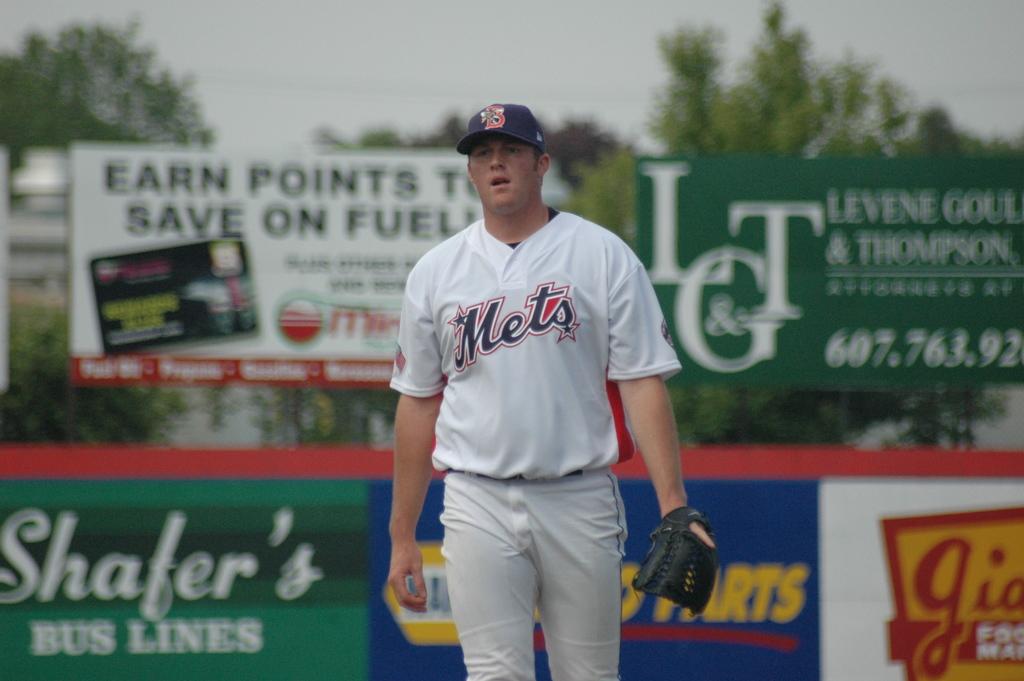Is he on the mets?
Ensure brevity in your answer.  Yes. 